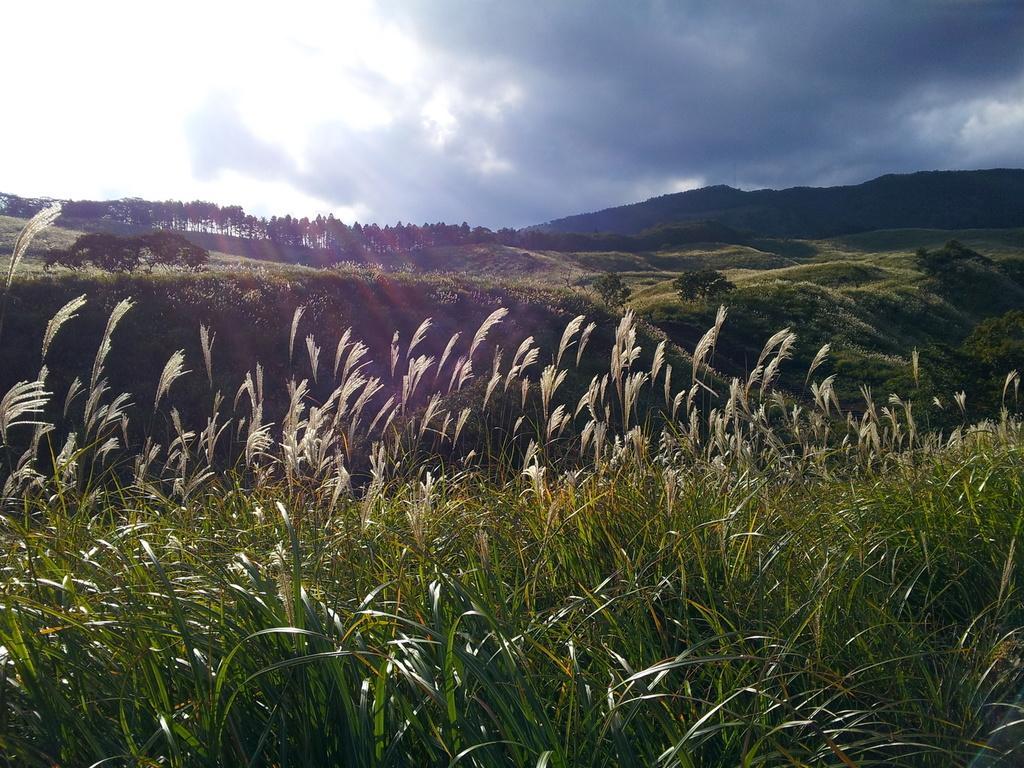How would you summarize this image in a sentence or two? In this image, we can see trees, hills and there are plants. At the top, there are clouds in the sky. 